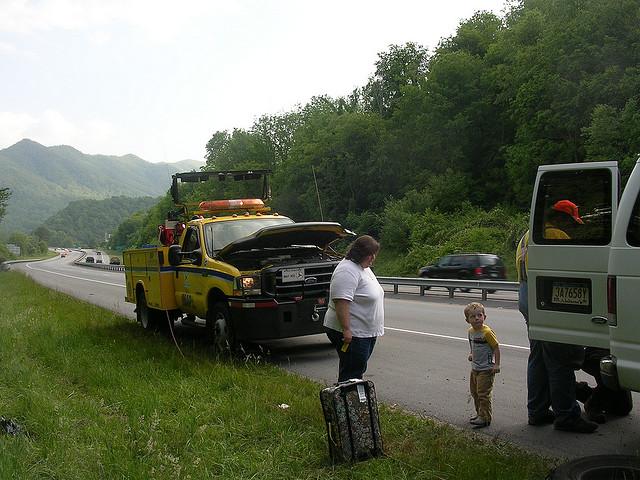What is the function of the yellow truck?
Answer briefly. Tow truck. Is the truck on a highway?
Quick response, please. Yes. How many people are there?
Keep it brief. 3. Is the woman slim?
Concise answer only. No. Can you tell from the license plate if the gathering is in the US?
Be succinct. Yes. 